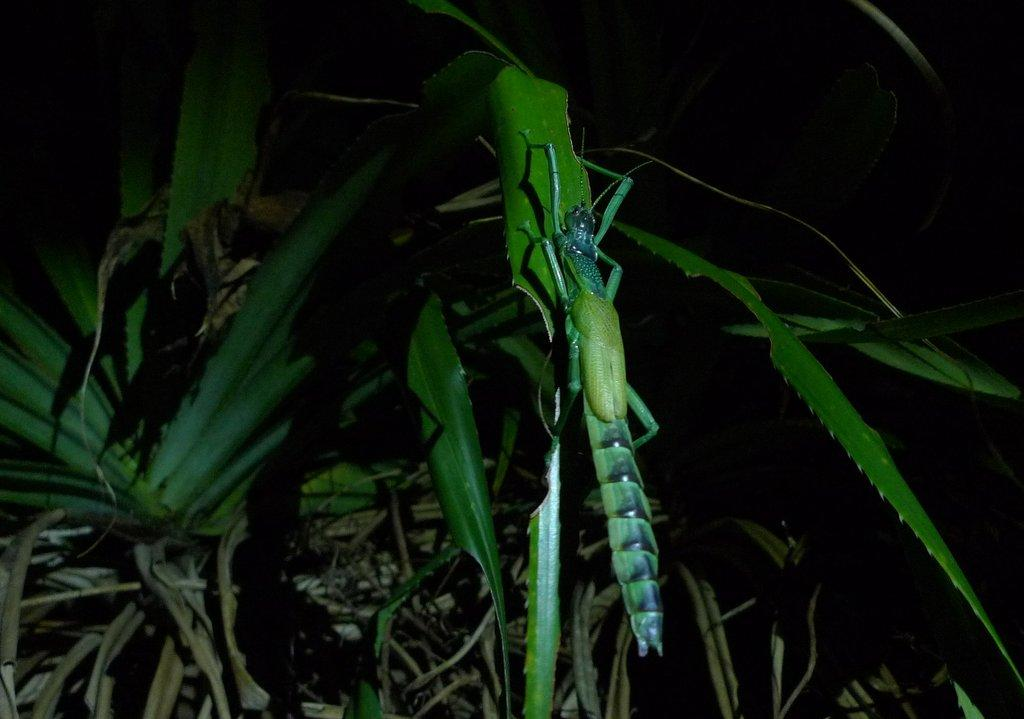What is the main subject in the middle of the image? There is an insect in the middle of the image. What else can be seen in the image besides the insect? Plants are visible in the image. What role does the manager play in the battle depicted in the image? There is no battle or manager present in the image; it features an insect and plants. 